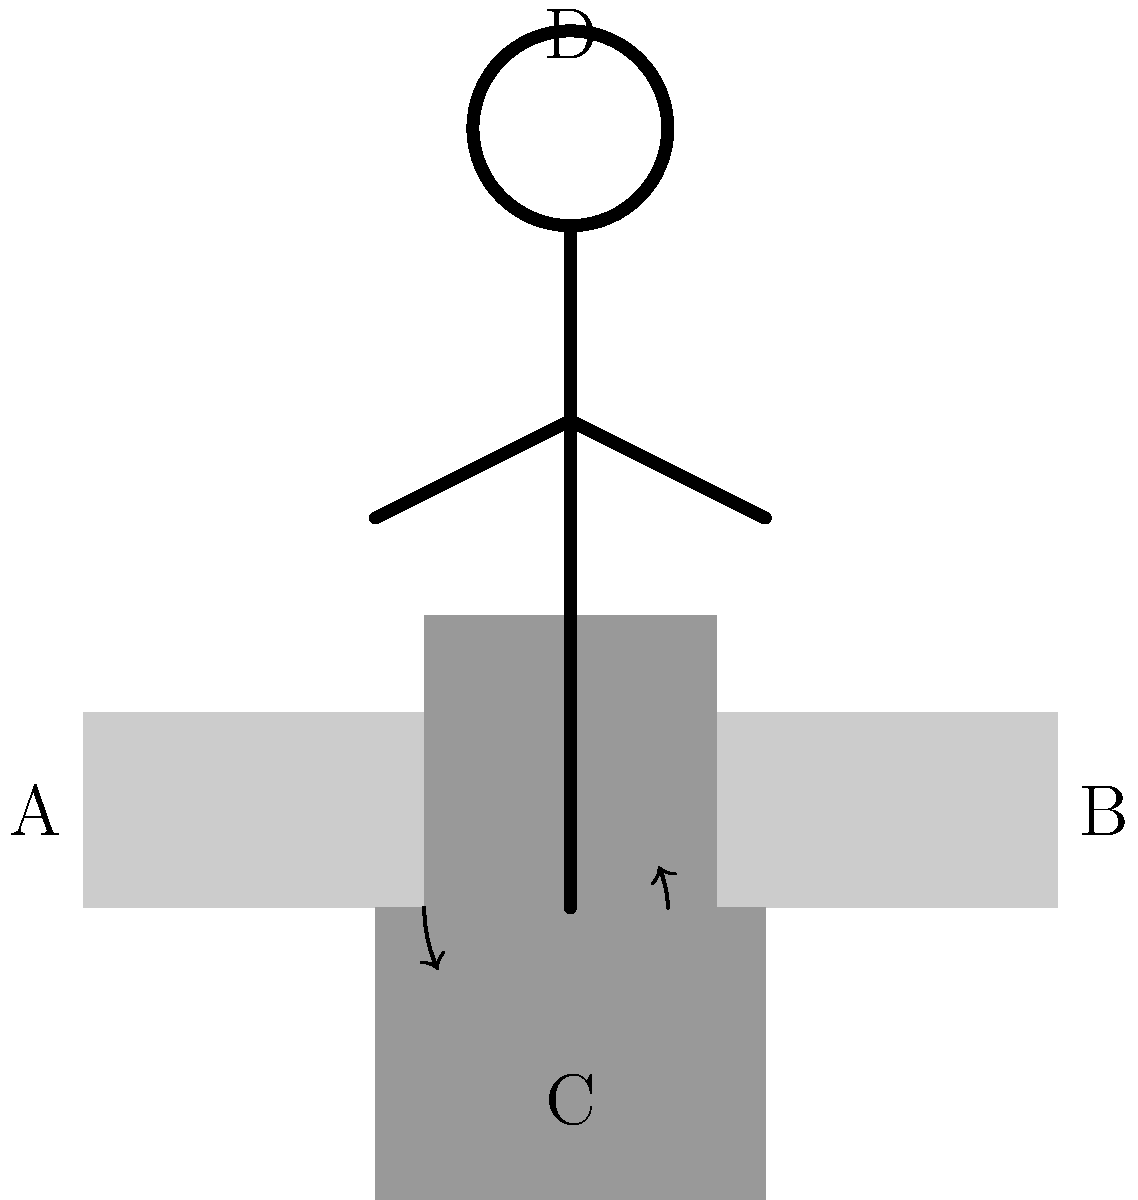In designing ergonomic classroom furniture for children, which angle (in degrees) between the seat and backrest (angle BAD in the diagram) is generally recommended to promote proper posture and reduce the risk of back pain? To determine the optimal angle between the seat and backrest for children's classroom furniture, we need to consider several factors:

1. Spinal alignment: The angle should support the natural curvature of the spine.
2. Weight distribution: It should allow for even distribution of body weight.
3. Comfort: The angle should provide comfort for extended sitting periods.
4. Adaptability: It should accommodate various body sizes and postures.

Research in ergonomics and child health has shown that:

1. A completely upright (90°) backrest can cause increased pressure on the spine.
2. A backrest that's too reclined (>110°) can lead to slouching and neck strain.
3. The ideal angle falls between these extremes, typically around 100-105°.

Specifically, studies have found that an angle of approximately 100° between the seat and backrest provides the best balance of spinal support, comfort, and adaptability for children in classroom settings.

This angle:
- Maintains the natural S-curve of the spine
- Reduces pressure on the lower back
- Allows for slight movement and position changes
- Encourages an upright posture without forcing rigidity

Therefore, the recommended angle between the seat and backrest (angle BAD in the diagram) for ergonomic classroom furniture designed for children is approximately 100°.
Answer: 100° 